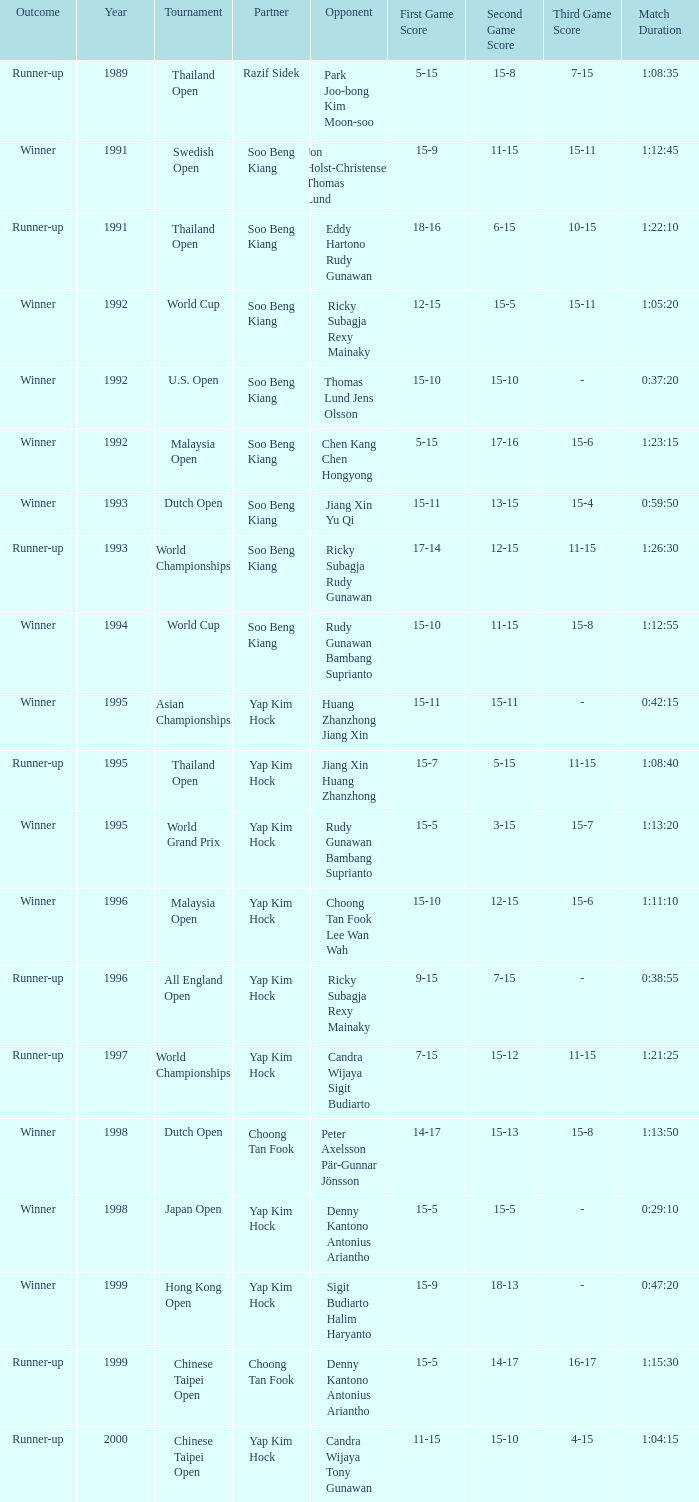Who was Choong Tan Fook's opponent in 1999? Denny Kantono Antonius Ariantho. 